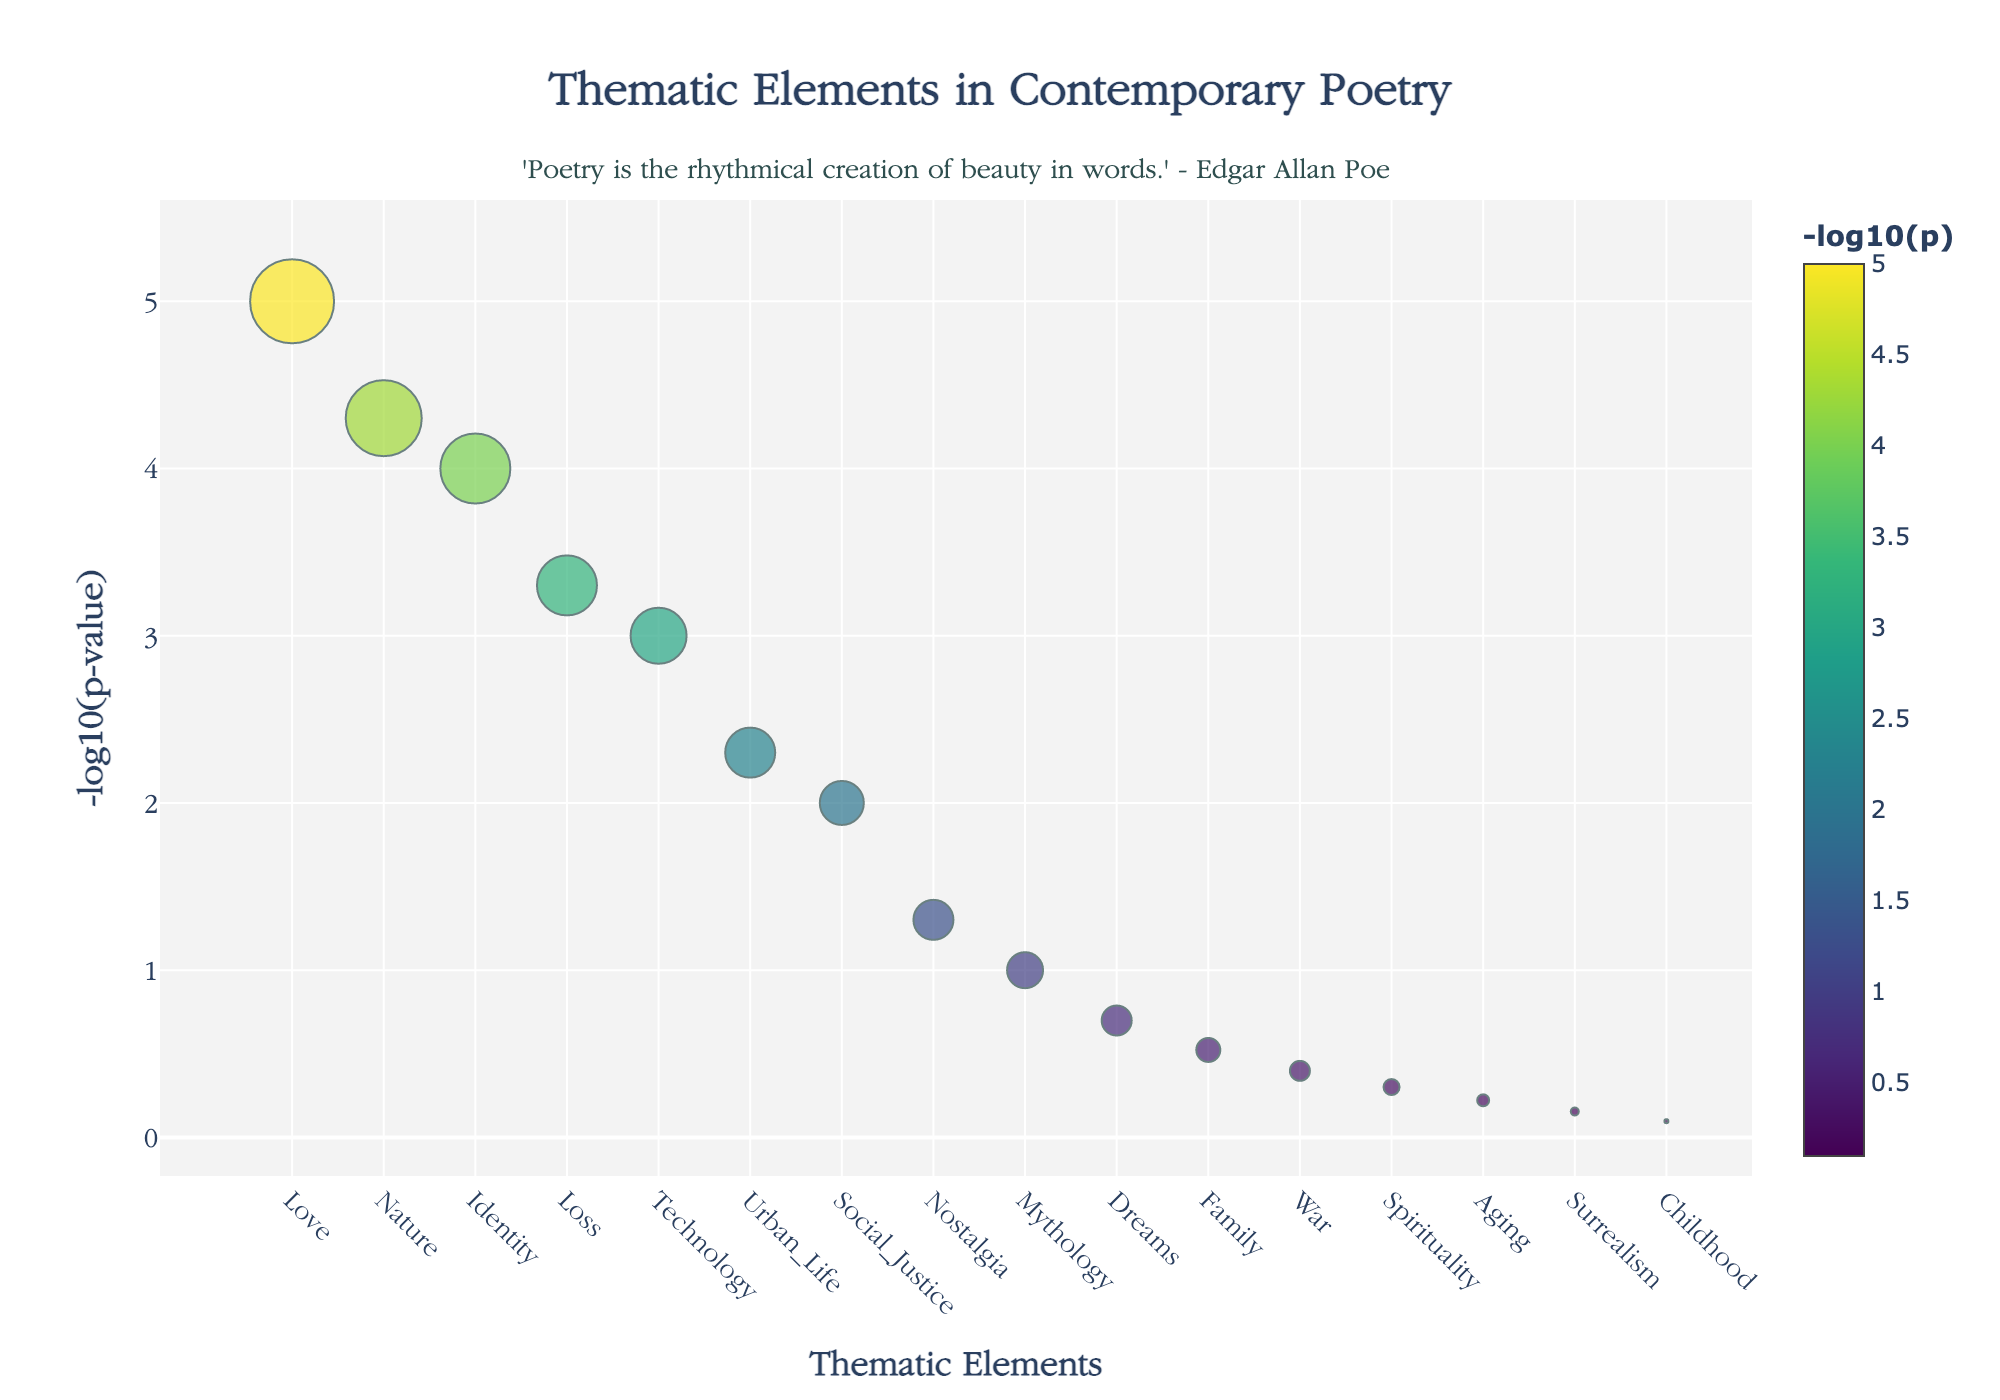What's the title of the plot? The title is positioned at the top center of the plot, below the x-axis. It reads: "Thematic Elements in Contemporary Poetry".
Answer: Thematic Elements in Contemporary Poetry Which thematic element has the highest frequency? The frequency can be observed by the size of the markers. The largest marker corresponds to the thematic element "Love", which has a frequency of 42.
Answer: Love What is the y-axis representing? The y-axis title reads "-log10(p-value)" indicating it represents the negative logarithm (base 10) of the p-value.
Answer: -log10(p-value) How many thematic elements have a p-value below 0.01? The y-axis represents -log10(p-value). A p-value of 0.01 corresponds to -log10(0.01) = 2. Any value above this indicates a p-value below 0.01. Elements with y-values above 2 are: Love, Nature, Identity, Loss, Technology, and Urban Life. There are 6 such elements.
Answer: 6 Which thematic element has the lowest p-value? The lowest p-value corresponds to the highest -log10(p-value) on the plot. The highest point on the plot corresponds to "Love".
Answer: Love How many thematic elements were analyzed in this plot? The number of thematic elements can be counted by observing the x-axis, which lists all of them. There are 16 thematic elements.
Answer: 16 What's the p-value for "Urban Life"? The "Urban Life" point can be found on the x-axis. Its y-value can be used to find the original p-value. -log10(p) for "Urban Life" matches approximately 2.3, implying p-value = 10^(-2.3) ≈ 0.005.
Answer: 0.005 Which thematic element is the least frequently occurring? The smallest marker on the plot indicates the lowest frequency. This corresponds to "Childhood" with a frequency of 2.
Answer: Childhood How does the frequency of "Technology" compare to "Nostalgia"? By observing the marker sizes, the marker for "Technology" is slightly larger than that for "Nostalgia". "Technology" has a frequency of 28, whereas "Nostalgia" has 20.
Answer: Technology has a higher frequency than Nostalgia Which thematic element has a p-value closest to 0.05? The p-value 0.05 corresponds to -log10(0.05) ≈ 1.3. The thematic element with y-value closest to 1.3 is "Nostalgia".
Answer: Nostalgia 